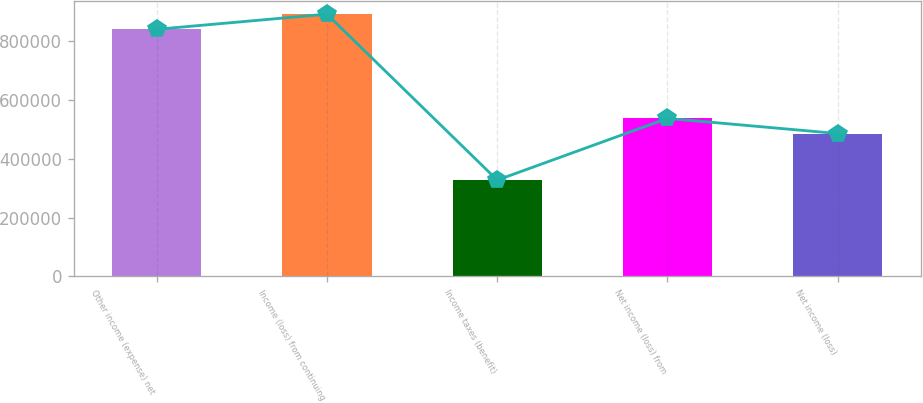Convert chart. <chart><loc_0><loc_0><loc_500><loc_500><bar_chart><fcel>Other income (expense) net<fcel>Income (loss) from continuing<fcel>Income taxes (benefit)<fcel>Net income (loss) from<fcel>Net income (loss)<nl><fcel>839338<fcel>890794<fcel>327274<fcel>536843<fcel>485387<nl></chart> 